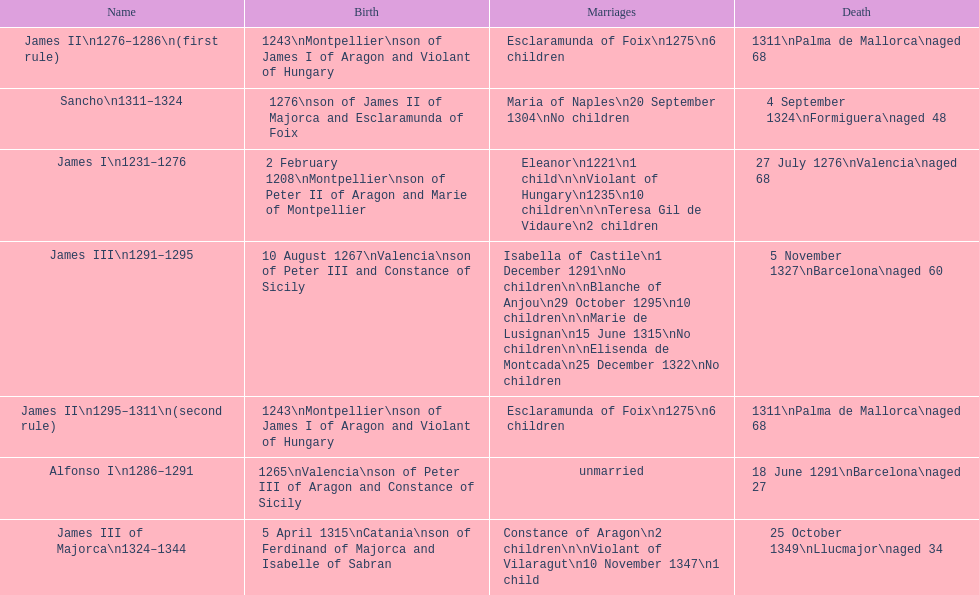Which two monarchs had no children? Alfonso I, Sancho. 